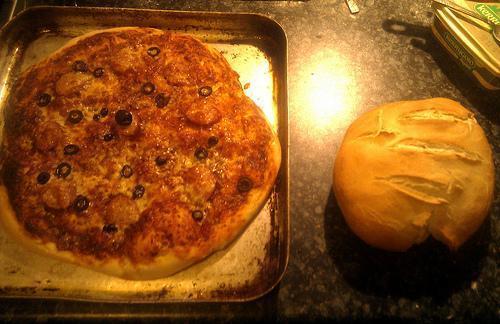How many pizzas are pictured?
Give a very brief answer. 1. How many loaves of bread are there?
Give a very brief answer. 1. How many slits are on the bread?
Give a very brief answer. 3. 